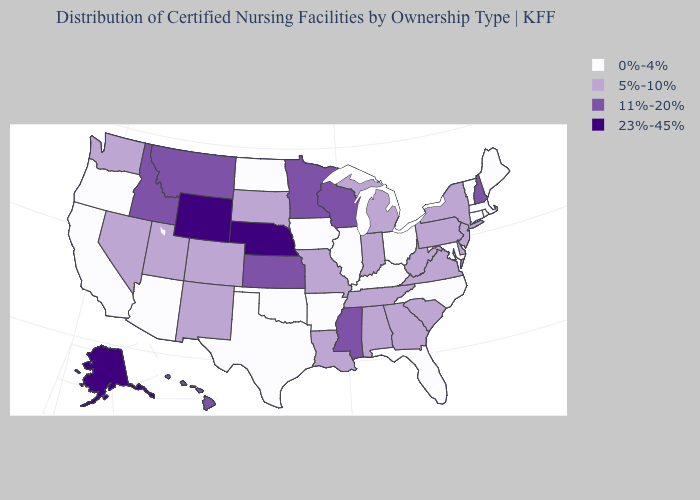What is the value of Montana?
Keep it brief. 11%-20%. Name the states that have a value in the range 5%-10%?
Be succinct. Alabama, Colorado, Delaware, Georgia, Indiana, Louisiana, Michigan, Missouri, Nevada, New Jersey, New Mexico, New York, Pennsylvania, South Carolina, South Dakota, Tennessee, Utah, Virginia, Washington, West Virginia. Name the states that have a value in the range 5%-10%?
Answer briefly. Alabama, Colorado, Delaware, Georgia, Indiana, Louisiana, Michigan, Missouri, Nevada, New Jersey, New Mexico, New York, Pennsylvania, South Carolina, South Dakota, Tennessee, Utah, Virginia, Washington, West Virginia. What is the lowest value in the USA?
Answer briefly. 0%-4%. What is the lowest value in the Northeast?
Write a very short answer. 0%-4%. Among the states that border Michigan , which have the highest value?
Give a very brief answer. Wisconsin. Name the states that have a value in the range 23%-45%?
Concise answer only. Alaska, Nebraska, Wyoming. Does the first symbol in the legend represent the smallest category?
Keep it brief. Yes. What is the highest value in the MidWest ?
Give a very brief answer. 23%-45%. Which states have the highest value in the USA?
Answer briefly. Alaska, Nebraska, Wyoming. What is the value of Hawaii?
Be succinct. 11%-20%. What is the value of New Jersey?
Concise answer only. 5%-10%. What is the lowest value in the MidWest?
Answer briefly. 0%-4%. Name the states that have a value in the range 11%-20%?
Short answer required. Hawaii, Idaho, Kansas, Minnesota, Mississippi, Montana, New Hampshire, Wisconsin. 